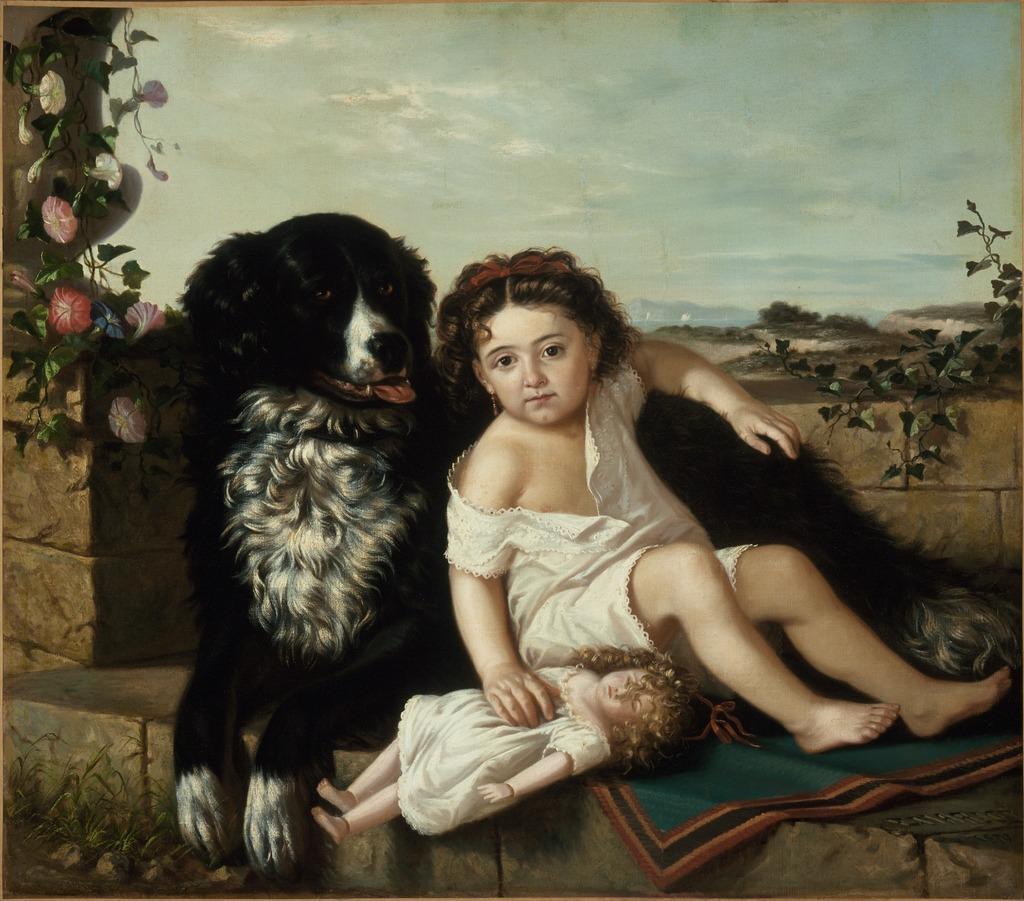Could you give a brief overview of what you see in this image? This looks like a painting. I can see a girl and a dog sitting on the wall. She is holding a doll in her hand. This looks like a carpet. I can see a plant with the colorful flowers. This is the sky. In the background, I can see the trees. 